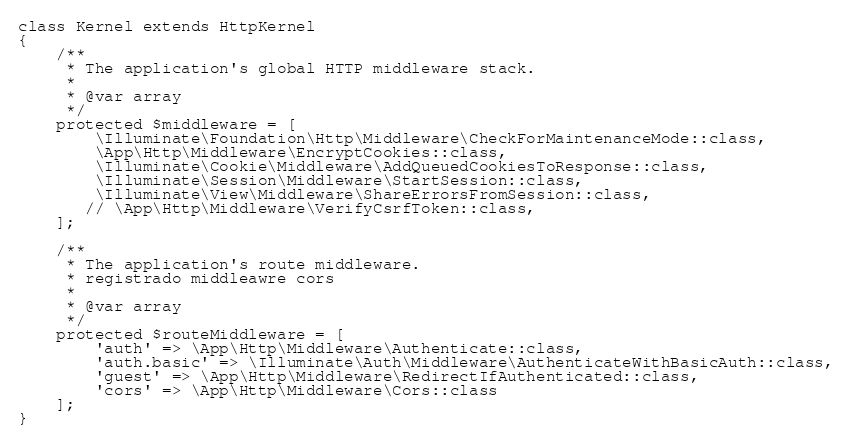Convert code to text. <code><loc_0><loc_0><loc_500><loc_500><_PHP_>class Kernel extends HttpKernel
{
    /**
     * The application's global HTTP middleware stack.
     *
     * @var array
     */
    protected $middleware = [
        \Illuminate\Foundation\Http\Middleware\CheckForMaintenanceMode::class,
        \App\Http\Middleware\EncryptCookies::class,
        \Illuminate\Cookie\Middleware\AddQueuedCookiesToResponse::class,
        \Illuminate\Session\Middleware\StartSession::class,
        \Illuminate\View\Middleware\ShareErrorsFromSession::class,
       // \App\Http\Middleware\VerifyCsrfToken::class,
    ];

    /**
     * The application's route middleware.
     * registrado middleawre cors
     *
     * @var array
     */
    protected $routeMiddleware = [
        'auth' => \App\Http\Middleware\Authenticate::class,
        'auth.basic' => \Illuminate\Auth\Middleware\AuthenticateWithBasicAuth::class,
        'guest' => \App\Http\Middleware\RedirectIfAuthenticated::class,
        'cors' => \App\Http\Middleware\Cors::class
    ];
}
</code> 